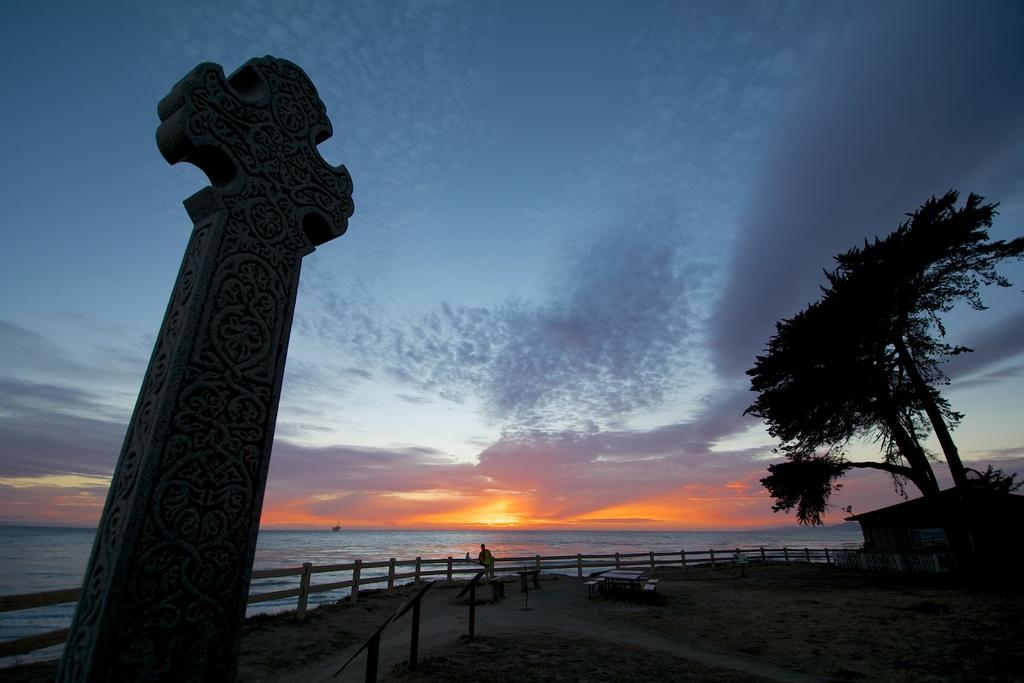What type of furniture is present in the image? There is a dining table in the image. Where are the persons located in the image? The persons are standing on the sand. What architectural feature can be seen in the image? There is a pillar in the image. What type of vegetation is present in the image? Trees are present in the image. What type of structure is visible in the image? There is a shed in the image. What type of barrier is visible in the image? A wooden fence is visible in the image. What natural element is present in the image? There is water in the image. What celestial body is visible in the image? The sun is visible in the image. What atmospheric condition is visible in the image? The sky with clouds is visible in the image. How does the bee contribute to the peace in the image? There are no bees present in the image, so it is not possible to determine their contribution to peace. What type of trouble is depicted in the image? There is no trouble depicted in the image; it features a dining table, persons standing on the sand, a pillar, trees, a shed, a wooden fence, water, the sun, and the sky with clouds. 